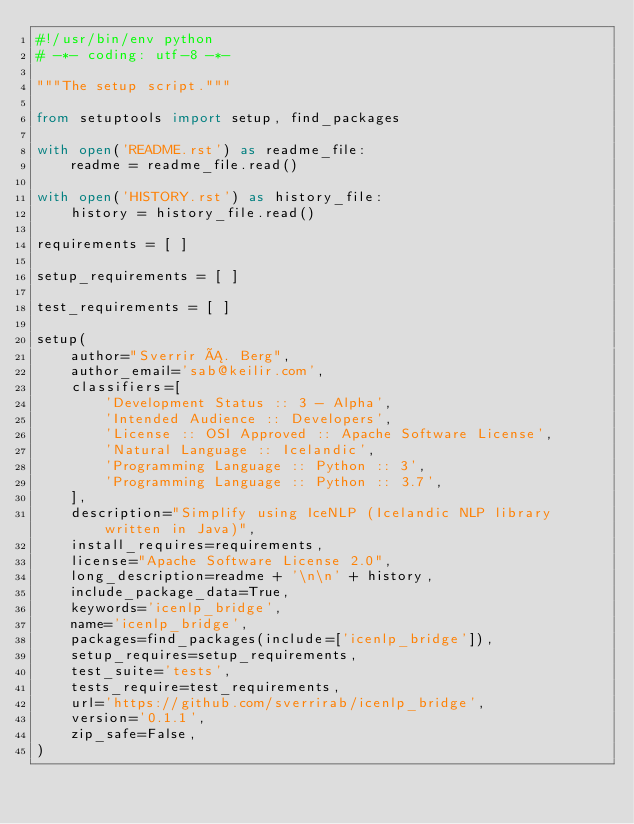Convert code to text. <code><loc_0><loc_0><loc_500><loc_500><_Python_>#!/usr/bin/env python
# -*- coding: utf-8 -*-

"""The setup script."""

from setuptools import setup, find_packages

with open('README.rst') as readme_file:
    readme = readme_file.read()

with open('HISTORY.rst') as history_file:
    history = history_file.read()

requirements = [ ]

setup_requirements = [ ]

test_requirements = [ ]

setup(
    author="Sverrir Á. Berg",
    author_email='sab@keilir.com',
    classifiers=[
        'Development Status :: 3 - Alpha',
        'Intended Audience :: Developers',
        'License :: OSI Approved :: Apache Software License',
        'Natural Language :: Icelandic',
        'Programming Language :: Python :: 3',
        'Programming Language :: Python :: 3.7',
    ],
    description="Simplify using IceNLP (Icelandic NLP library written in Java)",
    install_requires=requirements,
    license="Apache Software License 2.0",
    long_description=readme + '\n\n' + history,
    include_package_data=True,
    keywords='icenlp_bridge',
    name='icenlp_bridge',
    packages=find_packages(include=['icenlp_bridge']),
    setup_requires=setup_requirements,
    test_suite='tests',
    tests_require=test_requirements,
    url='https://github.com/sverrirab/icenlp_bridge',
    version='0.1.1',
    zip_safe=False,
)
</code> 